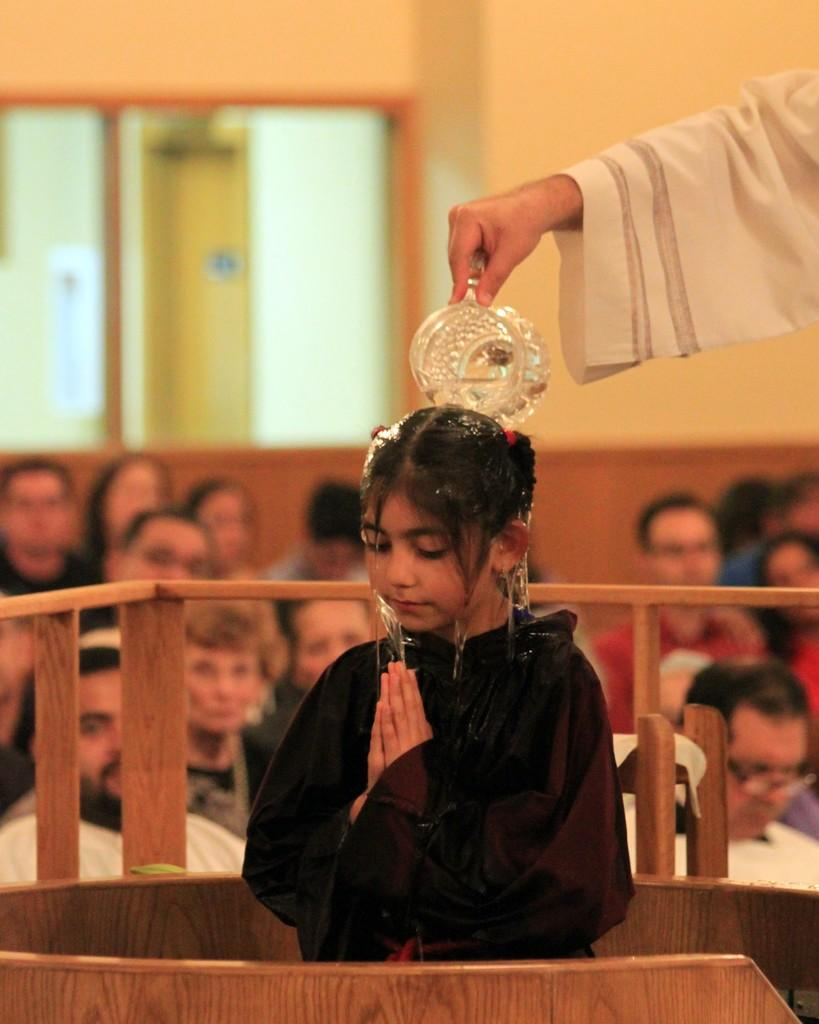What is the person in the image doing to the child? The person is pouring water on the child in the image. Can you describe the scene in the background of the image? There are people and windows visible in the background of the image, as well as a wall. What type of nerve is visible in the image? There is no nerve visible in the image; it features a person pouring water on a child and a background scene with people, windows, and a wall. 